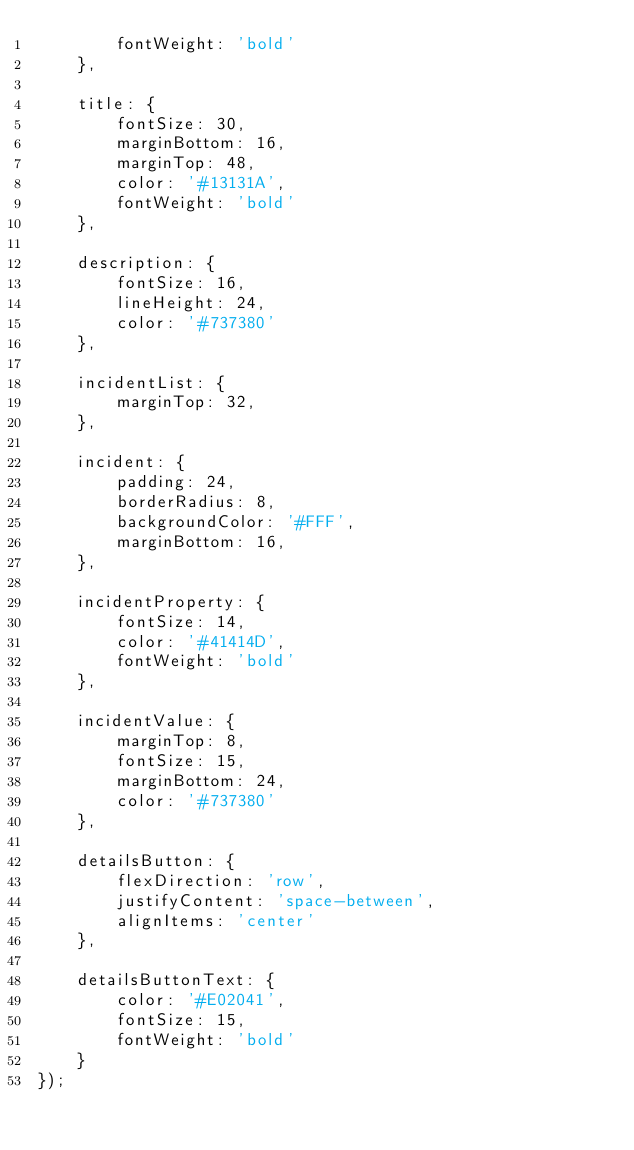Convert code to text. <code><loc_0><loc_0><loc_500><loc_500><_JavaScript_>        fontWeight: 'bold'
    },

    title: {
        fontSize: 30,
        marginBottom: 16,
        marginTop: 48,
        color: '#13131A',
        fontWeight: 'bold'
    },

    description: {
        fontSize: 16,
        lineHeight: 24,
        color: '#737380'
    },

    incidentList: {
        marginTop: 32,
    },

    incident: {
        padding: 24,
        borderRadius: 8,
        backgroundColor: '#FFF',
        marginBottom: 16,
    },

    incidentProperty: {
        fontSize: 14,
        color: '#41414D',
        fontWeight: 'bold'
    },

    incidentValue: {
        marginTop: 8,
        fontSize: 15,
        marginBottom: 24,
        color: '#737380'
    },

    detailsButton: {
        flexDirection: 'row',
        justifyContent: 'space-between',
        alignItems: 'center'
    },

    detailsButtonText: {
        color: '#E02041',
        fontSize: 15,
        fontWeight: 'bold'
    }
});</code> 